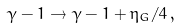<formula> <loc_0><loc_0><loc_500><loc_500>\gamma - 1 \rightarrow \gamma - 1 + \eta _ { G } / 4 \, ,</formula> 